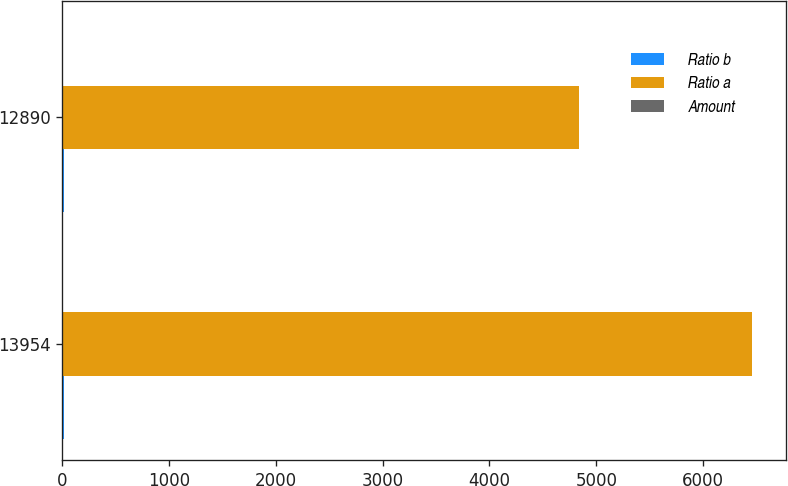Convert chart. <chart><loc_0><loc_0><loc_500><loc_500><stacked_bar_chart><ecel><fcel>13954<fcel>12890<nl><fcel>Ratio b<fcel>17.3<fcel>16<nl><fcel>Ratio a<fcel>6454<fcel>4840<nl><fcel>Amount<fcel>8<fcel>6<nl></chart> 